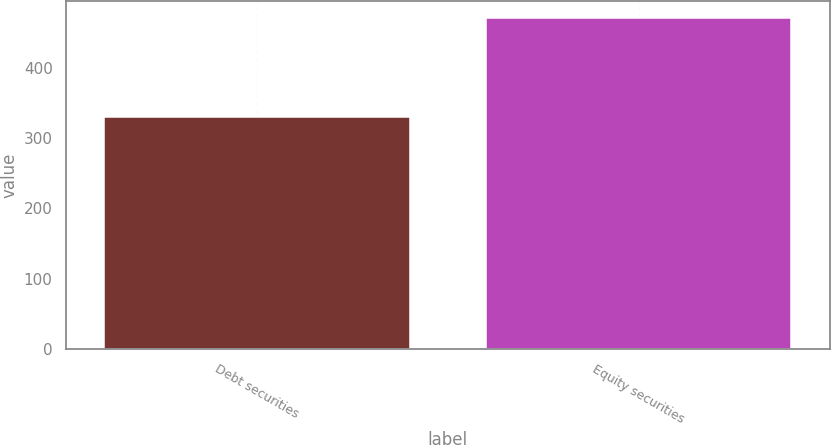Convert chart. <chart><loc_0><loc_0><loc_500><loc_500><bar_chart><fcel>Debt securities<fcel>Equity securities<nl><fcel>330<fcel>471<nl></chart> 